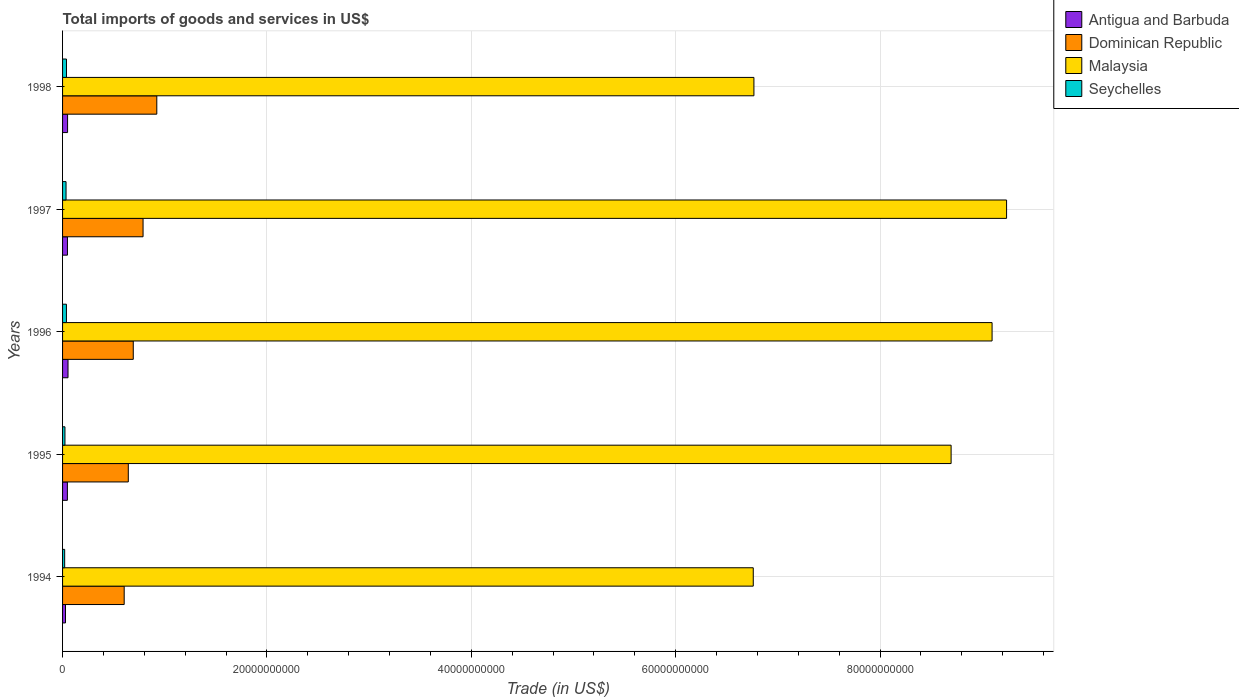How many different coloured bars are there?
Offer a very short reply. 4. How many groups of bars are there?
Make the answer very short. 5. How many bars are there on the 3rd tick from the top?
Offer a very short reply. 4. What is the label of the 1st group of bars from the top?
Keep it short and to the point. 1998. What is the total imports of goods and services in Antigua and Barbuda in 1994?
Provide a succinct answer. 2.86e+08. Across all years, what is the maximum total imports of goods and services in Antigua and Barbuda?
Provide a short and direct response. 5.33e+08. Across all years, what is the minimum total imports of goods and services in Seychelles?
Make the answer very short. 2.06e+08. In which year was the total imports of goods and services in Dominican Republic maximum?
Offer a very short reply. 1998. What is the total total imports of goods and services in Malaysia in the graph?
Provide a succinct answer. 4.06e+11. What is the difference between the total imports of goods and services in Antigua and Barbuda in 1997 and that in 1998?
Provide a succinct answer. -1.16e+07. What is the difference between the total imports of goods and services in Dominican Republic in 1996 and the total imports of goods and services in Antigua and Barbuda in 1998?
Provide a short and direct response. 6.43e+09. What is the average total imports of goods and services in Seychelles per year?
Ensure brevity in your answer.  3.08e+08. In the year 1995, what is the difference between the total imports of goods and services in Seychelles and total imports of goods and services in Antigua and Barbuda?
Your response must be concise. -2.40e+08. What is the ratio of the total imports of goods and services in Dominican Republic in 1994 to that in 1997?
Provide a short and direct response. 0.77. Is the total imports of goods and services in Antigua and Barbuda in 1994 less than that in 1995?
Offer a very short reply. Yes. What is the difference between the highest and the second highest total imports of goods and services in Dominican Republic?
Your response must be concise. 1.34e+09. What is the difference between the highest and the lowest total imports of goods and services in Antigua and Barbuda?
Offer a terse response. 2.47e+08. Is it the case that in every year, the sum of the total imports of goods and services in Antigua and Barbuda and total imports of goods and services in Seychelles is greater than the sum of total imports of goods and services in Dominican Republic and total imports of goods and services in Malaysia?
Your answer should be compact. No. What does the 1st bar from the top in 1994 represents?
Keep it short and to the point. Seychelles. What does the 2nd bar from the bottom in 1998 represents?
Make the answer very short. Dominican Republic. Is it the case that in every year, the sum of the total imports of goods and services in Seychelles and total imports of goods and services in Malaysia is greater than the total imports of goods and services in Dominican Republic?
Keep it short and to the point. Yes. How many bars are there?
Keep it short and to the point. 20. Are all the bars in the graph horizontal?
Give a very brief answer. Yes. How many years are there in the graph?
Provide a succinct answer. 5. Does the graph contain grids?
Give a very brief answer. Yes. Where does the legend appear in the graph?
Ensure brevity in your answer.  Top right. How many legend labels are there?
Make the answer very short. 4. What is the title of the graph?
Your response must be concise. Total imports of goods and services in US$. What is the label or title of the X-axis?
Provide a succinct answer. Trade (in US$). What is the label or title of the Y-axis?
Give a very brief answer. Years. What is the Trade (in US$) in Antigua and Barbuda in 1994?
Provide a succinct answer. 2.86e+08. What is the Trade (in US$) in Dominican Republic in 1994?
Ensure brevity in your answer.  6.03e+09. What is the Trade (in US$) of Malaysia in 1994?
Keep it short and to the point. 6.76e+1. What is the Trade (in US$) in Seychelles in 1994?
Make the answer very short. 2.06e+08. What is the Trade (in US$) in Antigua and Barbuda in 1995?
Provide a succinct answer. 4.72e+08. What is the Trade (in US$) in Dominican Republic in 1995?
Make the answer very short. 6.43e+09. What is the Trade (in US$) of Malaysia in 1995?
Keep it short and to the point. 8.70e+1. What is the Trade (in US$) of Seychelles in 1995?
Keep it short and to the point. 2.33e+08. What is the Trade (in US$) in Antigua and Barbuda in 1996?
Your answer should be compact. 5.33e+08. What is the Trade (in US$) of Dominican Republic in 1996?
Keep it short and to the point. 6.92e+09. What is the Trade (in US$) in Malaysia in 1996?
Give a very brief answer. 9.10e+1. What is the Trade (in US$) of Seychelles in 1996?
Offer a terse response. 3.79e+08. What is the Trade (in US$) of Antigua and Barbuda in 1997?
Your response must be concise. 4.78e+08. What is the Trade (in US$) of Dominican Republic in 1997?
Offer a very short reply. 7.88e+09. What is the Trade (in US$) in Malaysia in 1997?
Offer a terse response. 9.24e+1. What is the Trade (in US$) in Seychelles in 1997?
Your answer should be compact. 3.40e+08. What is the Trade (in US$) of Antigua and Barbuda in 1998?
Provide a short and direct response. 4.90e+08. What is the Trade (in US$) in Dominican Republic in 1998?
Offer a terse response. 9.22e+09. What is the Trade (in US$) of Malaysia in 1998?
Your answer should be very brief. 6.77e+1. What is the Trade (in US$) of Seychelles in 1998?
Your response must be concise. 3.83e+08. Across all years, what is the maximum Trade (in US$) of Antigua and Barbuda?
Give a very brief answer. 5.33e+08. Across all years, what is the maximum Trade (in US$) of Dominican Republic?
Give a very brief answer. 9.22e+09. Across all years, what is the maximum Trade (in US$) of Malaysia?
Provide a succinct answer. 9.24e+1. Across all years, what is the maximum Trade (in US$) in Seychelles?
Your answer should be very brief. 3.83e+08. Across all years, what is the minimum Trade (in US$) in Antigua and Barbuda?
Provide a succinct answer. 2.86e+08. Across all years, what is the minimum Trade (in US$) of Dominican Republic?
Make the answer very short. 6.03e+09. Across all years, what is the minimum Trade (in US$) in Malaysia?
Your answer should be very brief. 6.76e+1. Across all years, what is the minimum Trade (in US$) in Seychelles?
Your answer should be very brief. 2.06e+08. What is the total Trade (in US$) of Antigua and Barbuda in the graph?
Keep it short and to the point. 2.26e+09. What is the total Trade (in US$) in Dominican Republic in the graph?
Ensure brevity in your answer.  3.65e+1. What is the total Trade (in US$) of Malaysia in the graph?
Make the answer very short. 4.06e+11. What is the total Trade (in US$) of Seychelles in the graph?
Your answer should be very brief. 1.54e+09. What is the difference between the Trade (in US$) of Antigua and Barbuda in 1994 and that in 1995?
Keep it short and to the point. -1.86e+08. What is the difference between the Trade (in US$) of Dominican Republic in 1994 and that in 1995?
Your response must be concise. -4.01e+08. What is the difference between the Trade (in US$) of Malaysia in 1994 and that in 1995?
Offer a terse response. -1.94e+1. What is the difference between the Trade (in US$) in Seychelles in 1994 and that in 1995?
Provide a succinct answer. -2.68e+07. What is the difference between the Trade (in US$) in Antigua and Barbuda in 1994 and that in 1996?
Your answer should be very brief. -2.47e+08. What is the difference between the Trade (in US$) of Dominican Republic in 1994 and that in 1996?
Ensure brevity in your answer.  -8.88e+08. What is the difference between the Trade (in US$) in Malaysia in 1994 and that in 1996?
Provide a short and direct response. -2.34e+1. What is the difference between the Trade (in US$) in Seychelles in 1994 and that in 1996?
Provide a succinct answer. -1.72e+08. What is the difference between the Trade (in US$) in Antigua and Barbuda in 1994 and that in 1997?
Make the answer very short. -1.92e+08. What is the difference between the Trade (in US$) of Dominican Republic in 1994 and that in 1997?
Give a very brief answer. -1.85e+09. What is the difference between the Trade (in US$) of Malaysia in 1994 and that in 1997?
Offer a very short reply. -2.48e+1. What is the difference between the Trade (in US$) of Seychelles in 1994 and that in 1997?
Your response must be concise. -1.34e+08. What is the difference between the Trade (in US$) of Antigua and Barbuda in 1994 and that in 1998?
Give a very brief answer. -2.04e+08. What is the difference between the Trade (in US$) of Dominican Republic in 1994 and that in 1998?
Give a very brief answer. -3.19e+09. What is the difference between the Trade (in US$) in Malaysia in 1994 and that in 1998?
Give a very brief answer. -6.37e+07. What is the difference between the Trade (in US$) in Seychelles in 1994 and that in 1998?
Your answer should be very brief. -1.77e+08. What is the difference between the Trade (in US$) of Antigua and Barbuda in 1995 and that in 1996?
Your answer should be compact. -6.09e+07. What is the difference between the Trade (in US$) in Dominican Republic in 1995 and that in 1996?
Offer a terse response. -4.87e+08. What is the difference between the Trade (in US$) in Malaysia in 1995 and that in 1996?
Offer a very short reply. -4.01e+09. What is the difference between the Trade (in US$) in Seychelles in 1995 and that in 1996?
Keep it short and to the point. -1.46e+08. What is the difference between the Trade (in US$) in Antigua and Barbuda in 1995 and that in 1997?
Ensure brevity in your answer.  -5.84e+06. What is the difference between the Trade (in US$) in Dominican Republic in 1995 and that in 1997?
Your answer should be compact. -1.44e+09. What is the difference between the Trade (in US$) in Malaysia in 1995 and that in 1997?
Ensure brevity in your answer.  -5.43e+09. What is the difference between the Trade (in US$) of Seychelles in 1995 and that in 1997?
Provide a succinct answer. -1.08e+08. What is the difference between the Trade (in US$) in Antigua and Barbuda in 1995 and that in 1998?
Offer a very short reply. -1.75e+07. What is the difference between the Trade (in US$) of Dominican Republic in 1995 and that in 1998?
Ensure brevity in your answer.  -2.79e+09. What is the difference between the Trade (in US$) of Malaysia in 1995 and that in 1998?
Your response must be concise. 1.93e+1. What is the difference between the Trade (in US$) of Seychelles in 1995 and that in 1998?
Give a very brief answer. -1.50e+08. What is the difference between the Trade (in US$) of Antigua and Barbuda in 1996 and that in 1997?
Make the answer very short. 5.50e+07. What is the difference between the Trade (in US$) of Dominican Republic in 1996 and that in 1997?
Ensure brevity in your answer.  -9.58e+08. What is the difference between the Trade (in US$) of Malaysia in 1996 and that in 1997?
Provide a short and direct response. -1.42e+09. What is the difference between the Trade (in US$) of Seychelles in 1996 and that in 1997?
Your answer should be very brief. 3.82e+07. What is the difference between the Trade (in US$) of Antigua and Barbuda in 1996 and that in 1998?
Provide a short and direct response. 4.34e+07. What is the difference between the Trade (in US$) in Dominican Republic in 1996 and that in 1998?
Provide a succinct answer. -2.30e+09. What is the difference between the Trade (in US$) in Malaysia in 1996 and that in 1998?
Keep it short and to the point. 2.33e+1. What is the difference between the Trade (in US$) in Seychelles in 1996 and that in 1998?
Your answer should be very brief. -4.37e+06. What is the difference between the Trade (in US$) of Antigua and Barbuda in 1997 and that in 1998?
Give a very brief answer. -1.16e+07. What is the difference between the Trade (in US$) of Dominican Republic in 1997 and that in 1998?
Your response must be concise. -1.34e+09. What is the difference between the Trade (in US$) of Malaysia in 1997 and that in 1998?
Ensure brevity in your answer.  2.47e+1. What is the difference between the Trade (in US$) of Seychelles in 1997 and that in 1998?
Offer a terse response. -4.26e+07. What is the difference between the Trade (in US$) of Antigua and Barbuda in 1994 and the Trade (in US$) of Dominican Republic in 1995?
Provide a succinct answer. -6.15e+09. What is the difference between the Trade (in US$) in Antigua and Barbuda in 1994 and the Trade (in US$) in Malaysia in 1995?
Your answer should be very brief. -8.67e+1. What is the difference between the Trade (in US$) of Antigua and Barbuda in 1994 and the Trade (in US$) of Seychelles in 1995?
Your answer should be very brief. 5.35e+07. What is the difference between the Trade (in US$) of Dominican Republic in 1994 and the Trade (in US$) of Malaysia in 1995?
Provide a succinct answer. -8.09e+1. What is the difference between the Trade (in US$) of Dominican Republic in 1994 and the Trade (in US$) of Seychelles in 1995?
Your answer should be very brief. 5.80e+09. What is the difference between the Trade (in US$) of Malaysia in 1994 and the Trade (in US$) of Seychelles in 1995?
Your response must be concise. 6.74e+1. What is the difference between the Trade (in US$) of Antigua and Barbuda in 1994 and the Trade (in US$) of Dominican Republic in 1996?
Provide a short and direct response. -6.63e+09. What is the difference between the Trade (in US$) of Antigua and Barbuda in 1994 and the Trade (in US$) of Malaysia in 1996?
Provide a short and direct response. -9.07e+1. What is the difference between the Trade (in US$) in Antigua and Barbuda in 1994 and the Trade (in US$) in Seychelles in 1996?
Provide a short and direct response. -9.22e+07. What is the difference between the Trade (in US$) in Dominican Republic in 1994 and the Trade (in US$) in Malaysia in 1996?
Provide a succinct answer. -8.49e+1. What is the difference between the Trade (in US$) of Dominican Republic in 1994 and the Trade (in US$) of Seychelles in 1996?
Provide a succinct answer. 5.65e+09. What is the difference between the Trade (in US$) of Malaysia in 1994 and the Trade (in US$) of Seychelles in 1996?
Give a very brief answer. 6.72e+1. What is the difference between the Trade (in US$) of Antigua and Barbuda in 1994 and the Trade (in US$) of Dominican Republic in 1997?
Ensure brevity in your answer.  -7.59e+09. What is the difference between the Trade (in US$) in Antigua and Barbuda in 1994 and the Trade (in US$) in Malaysia in 1997?
Provide a short and direct response. -9.21e+1. What is the difference between the Trade (in US$) in Antigua and Barbuda in 1994 and the Trade (in US$) in Seychelles in 1997?
Make the answer very short. -5.40e+07. What is the difference between the Trade (in US$) in Dominican Republic in 1994 and the Trade (in US$) in Malaysia in 1997?
Make the answer very short. -8.63e+1. What is the difference between the Trade (in US$) in Dominican Republic in 1994 and the Trade (in US$) in Seychelles in 1997?
Offer a very short reply. 5.69e+09. What is the difference between the Trade (in US$) of Malaysia in 1994 and the Trade (in US$) of Seychelles in 1997?
Give a very brief answer. 6.73e+1. What is the difference between the Trade (in US$) in Antigua and Barbuda in 1994 and the Trade (in US$) in Dominican Republic in 1998?
Make the answer very short. -8.93e+09. What is the difference between the Trade (in US$) of Antigua and Barbuda in 1994 and the Trade (in US$) of Malaysia in 1998?
Ensure brevity in your answer.  -6.74e+1. What is the difference between the Trade (in US$) in Antigua and Barbuda in 1994 and the Trade (in US$) in Seychelles in 1998?
Ensure brevity in your answer.  -9.66e+07. What is the difference between the Trade (in US$) in Dominican Republic in 1994 and the Trade (in US$) in Malaysia in 1998?
Give a very brief answer. -6.16e+1. What is the difference between the Trade (in US$) of Dominican Republic in 1994 and the Trade (in US$) of Seychelles in 1998?
Your answer should be very brief. 5.65e+09. What is the difference between the Trade (in US$) in Malaysia in 1994 and the Trade (in US$) in Seychelles in 1998?
Offer a terse response. 6.72e+1. What is the difference between the Trade (in US$) of Antigua and Barbuda in 1995 and the Trade (in US$) of Dominican Republic in 1996?
Provide a succinct answer. -6.45e+09. What is the difference between the Trade (in US$) in Antigua and Barbuda in 1995 and the Trade (in US$) in Malaysia in 1996?
Provide a short and direct response. -9.05e+1. What is the difference between the Trade (in US$) in Antigua and Barbuda in 1995 and the Trade (in US$) in Seychelles in 1996?
Give a very brief answer. 9.38e+07. What is the difference between the Trade (in US$) in Dominican Republic in 1995 and the Trade (in US$) in Malaysia in 1996?
Keep it short and to the point. -8.45e+1. What is the difference between the Trade (in US$) in Dominican Republic in 1995 and the Trade (in US$) in Seychelles in 1996?
Your answer should be compact. 6.05e+09. What is the difference between the Trade (in US$) of Malaysia in 1995 and the Trade (in US$) of Seychelles in 1996?
Make the answer very short. 8.66e+1. What is the difference between the Trade (in US$) of Antigua and Barbuda in 1995 and the Trade (in US$) of Dominican Republic in 1997?
Your answer should be very brief. -7.40e+09. What is the difference between the Trade (in US$) in Antigua and Barbuda in 1995 and the Trade (in US$) in Malaysia in 1997?
Your response must be concise. -9.19e+1. What is the difference between the Trade (in US$) of Antigua and Barbuda in 1995 and the Trade (in US$) of Seychelles in 1997?
Your answer should be very brief. 1.32e+08. What is the difference between the Trade (in US$) in Dominican Republic in 1995 and the Trade (in US$) in Malaysia in 1997?
Provide a short and direct response. -8.59e+1. What is the difference between the Trade (in US$) of Dominican Republic in 1995 and the Trade (in US$) of Seychelles in 1997?
Keep it short and to the point. 6.09e+09. What is the difference between the Trade (in US$) of Malaysia in 1995 and the Trade (in US$) of Seychelles in 1997?
Keep it short and to the point. 8.66e+1. What is the difference between the Trade (in US$) of Antigua and Barbuda in 1995 and the Trade (in US$) of Dominican Republic in 1998?
Offer a terse response. -8.75e+09. What is the difference between the Trade (in US$) in Antigua and Barbuda in 1995 and the Trade (in US$) in Malaysia in 1998?
Make the answer very short. -6.72e+1. What is the difference between the Trade (in US$) in Antigua and Barbuda in 1995 and the Trade (in US$) in Seychelles in 1998?
Provide a succinct answer. 8.94e+07. What is the difference between the Trade (in US$) of Dominican Republic in 1995 and the Trade (in US$) of Malaysia in 1998?
Your answer should be compact. -6.12e+1. What is the difference between the Trade (in US$) in Dominican Republic in 1995 and the Trade (in US$) in Seychelles in 1998?
Provide a succinct answer. 6.05e+09. What is the difference between the Trade (in US$) of Malaysia in 1995 and the Trade (in US$) of Seychelles in 1998?
Ensure brevity in your answer.  8.66e+1. What is the difference between the Trade (in US$) of Antigua and Barbuda in 1996 and the Trade (in US$) of Dominican Republic in 1997?
Offer a terse response. -7.34e+09. What is the difference between the Trade (in US$) in Antigua and Barbuda in 1996 and the Trade (in US$) in Malaysia in 1997?
Keep it short and to the point. -9.18e+1. What is the difference between the Trade (in US$) in Antigua and Barbuda in 1996 and the Trade (in US$) in Seychelles in 1997?
Your response must be concise. 1.93e+08. What is the difference between the Trade (in US$) of Dominican Republic in 1996 and the Trade (in US$) of Malaysia in 1997?
Your answer should be compact. -8.55e+1. What is the difference between the Trade (in US$) in Dominican Republic in 1996 and the Trade (in US$) in Seychelles in 1997?
Provide a succinct answer. 6.58e+09. What is the difference between the Trade (in US$) in Malaysia in 1996 and the Trade (in US$) in Seychelles in 1997?
Your response must be concise. 9.06e+1. What is the difference between the Trade (in US$) in Antigua and Barbuda in 1996 and the Trade (in US$) in Dominican Republic in 1998?
Ensure brevity in your answer.  -8.69e+09. What is the difference between the Trade (in US$) in Antigua and Barbuda in 1996 and the Trade (in US$) in Malaysia in 1998?
Offer a terse response. -6.71e+1. What is the difference between the Trade (in US$) in Antigua and Barbuda in 1996 and the Trade (in US$) in Seychelles in 1998?
Provide a succinct answer. 1.50e+08. What is the difference between the Trade (in US$) in Dominican Republic in 1996 and the Trade (in US$) in Malaysia in 1998?
Ensure brevity in your answer.  -6.07e+1. What is the difference between the Trade (in US$) of Dominican Republic in 1996 and the Trade (in US$) of Seychelles in 1998?
Your response must be concise. 6.54e+09. What is the difference between the Trade (in US$) of Malaysia in 1996 and the Trade (in US$) of Seychelles in 1998?
Make the answer very short. 9.06e+1. What is the difference between the Trade (in US$) in Antigua and Barbuda in 1997 and the Trade (in US$) in Dominican Republic in 1998?
Provide a succinct answer. -8.74e+09. What is the difference between the Trade (in US$) in Antigua and Barbuda in 1997 and the Trade (in US$) in Malaysia in 1998?
Provide a succinct answer. -6.72e+1. What is the difference between the Trade (in US$) of Antigua and Barbuda in 1997 and the Trade (in US$) of Seychelles in 1998?
Make the answer very short. 9.53e+07. What is the difference between the Trade (in US$) of Dominican Republic in 1997 and the Trade (in US$) of Malaysia in 1998?
Offer a terse response. -5.98e+1. What is the difference between the Trade (in US$) of Dominican Republic in 1997 and the Trade (in US$) of Seychelles in 1998?
Provide a short and direct response. 7.49e+09. What is the difference between the Trade (in US$) in Malaysia in 1997 and the Trade (in US$) in Seychelles in 1998?
Ensure brevity in your answer.  9.20e+1. What is the average Trade (in US$) of Antigua and Barbuda per year?
Make the answer very short. 4.52e+08. What is the average Trade (in US$) of Dominican Republic per year?
Ensure brevity in your answer.  7.30e+09. What is the average Trade (in US$) of Malaysia per year?
Make the answer very short. 8.11e+1. What is the average Trade (in US$) in Seychelles per year?
Offer a very short reply. 3.08e+08. In the year 1994, what is the difference between the Trade (in US$) in Antigua and Barbuda and Trade (in US$) in Dominican Republic?
Your answer should be very brief. -5.74e+09. In the year 1994, what is the difference between the Trade (in US$) in Antigua and Barbuda and Trade (in US$) in Malaysia?
Make the answer very short. -6.73e+1. In the year 1994, what is the difference between the Trade (in US$) in Antigua and Barbuda and Trade (in US$) in Seychelles?
Provide a short and direct response. 8.02e+07. In the year 1994, what is the difference between the Trade (in US$) of Dominican Republic and Trade (in US$) of Malaysia?
Your answer should be compact. -6.16e+1. In the year 1994, what is the difference between the Trade (in US$) in Dominican Republic and Trade (in US$) in Seychelles?
Give a very brief answer. 5.82e+09. In the year 1994, what is the difference between the Trade (in US$) in Malaysia and Trade (in US$) in Seychelles?
Ensure brevity in your answer.  6.74e+1. In the year 1995, what is the difference between the Trade (in US$) in Antigua and Barbuda and Trade (in US$) in Dominican Republic?
Provide a succinct answer. -5.96e+09. In the year 1995, what is the difference between the Trade (in US$) of Antigua and Barbuda and Trade (in US$) of Malaysia?
Give a very brief answer. -8.65e+1. In the year 1995, what is the difference between the Trade (in US$) of Antigua and Barbuda and Trade (in US$) of Seychelles?
Keep it short and to the point. 2.40e+08. In the year 1995, what is the difference between the Trade (in US$) in Dominican Republic and Trade (in US$) in Malaysia?
Your response must be concise. -8.05e+1. In the year 1995, what is the difference between the Trade (in US$) of Dominican Republic and Trade (in US$) of Seychelles?
Your response must be concise. 6.20e+09. In the year 1995, what is the difference between the Trade (in US$) of Malaysia and Trade (in US$) of Seychelles?
Ensure brevity in your answer.  8.67e+1. In the year 1996, what is the difference between the Trade (in US$) of Antigua and Barbuda and Trade (in US$) of Dominican Republic?
Ensure brevity in your answer.  -6.39e+09. In the year 1996, what is the difference between the Trade (in US$) in Antigua and Barbuda and Trade (in US$) in Malaysia?
Provide a succinct answer. -9.04e+1. In the year 1996, what is the difference between the Trade (in US$) in Antigua and Barbuda and Trade (in US$) in Seychelles?
Offer a terse response. 1.55e+08. In the year 1996, what is the difference between the Trade (in US$) of Dominican Republic and Trade (in US$) of Malaysia?
Give a very brief answer. -8.40e+1. In the year 1996, what is the difference between the Trade (in US$) of Dominican Republic and Trade (in US$) of Seychelles?
Your response must be concise. 6.54e+09. In the year 1996, what is the difference between the Trade (in US$) of Malaysia and Trade (in US$) of Seychelles?
Your response must be concise. 9.06e+1. In the year 1997, what is the difference between the Trade (in US$) of Antigua and Barbuda and Trade (in US$) of Dominican Republic?
Offer a very short reply. -7.40e+09. In the year 1997, what is the difference between the Trade (in US$) of Antigua and Barbuda and Trade (in US$) of Malaysia?
Make the answer very short. -9.19e+1. In the year 1997, what is the difference between the Trade (in US$) in Antigua and Barbuda and Trade (in US$) in Seychelles?
Your answer should be very brief. 1.38e+08. In the year 1997, what is the difference between the Trade (in US$) in Dominican Republic and Trade (in US$) in Malaysia?
Your answer should be very brief. -8.45e+1. In the year 1997, what is the difference between the Trade (in US$) in Dominican Republic and Trade (in US$) in Seychelles?
Provide a succinct answer. 7.54e+09. In the year 1997, what is the difference between the Trade (in US$) of Malaysia and Trade (in US$) of Seychelles?
Give a very brief answer. 9.20e+1. In the year 1998, what is the difference between the Trade (in US$) in Antigua and Barbuda and Trade (in US$) in Dominican Republic?
Keep it short and to the point. -8.73e+09. In the year 1998, what is the difference between the Trade (in US$) of Antigua and Barbuda and Trade (in US$) of Malaysia?
Make the answer very short. -6.72e+1. In the year 1998, what is the difference between the Trade (in US$) in Antigua and Barbuda and Trade (in US$) in Seychelles?
Offer a terse response. 1.07e+08. In the year 1998, what is the difference between the Trade (in US$) in Dominican Republic and Trade (in US$) in Malaysia?
Your answer should be very brief. -5.84e+1. In the year 1998, what is the difference between the Trade (in US$) in Dominican Republic and Trade (in US$) in Seychelles?
Keep it short and to the point. 8.84e+09. In the year 1998, what is the difference between the Trade (in US$) of Malaysia and Trade (in US$) of Seychelles?
Provide a short and direct response. 6.73e+1. What is the ratio of the Trade (in US$) of Antigua and Barbuda in 1994 to that in 1995?
Make the answer very short. 0.61. What is the ratio of the Trade (in US$) of Dominican Republic in 1994 to that in 1995?
Your answer should be very brief. 0.94. What is the ratio of the Trade (in US$) of Malaysia in 1994 to that in 1995?
Provide a short and direct response. 0.78. What is the ratio of the Trade (in US$) in Seychelles in 1994 to that in 1995?
Your answer should be compact. 0.89. What is the ratio of the Trade (in US$) in Antigua and Barbuda in 1994 to that in 1996?
Your answer should be compact. 0.54. What is the ratio of the Trade (in US$) of Dominican Republic in 1994 to that in 1996?
Your answer should be very brief. 0.87. What is the ratio of the Trade (in US$) of Malaysia in 1994 to that in 1996?
Offer a very short reply. 0.74. What is the ratio of the Trade (in US$) in Seychelles in 1994 to that in 1996?
Provide a succinct answer. 0.54. What is the ratio of the Trade (in US$) of Antigua and Barbuda in 1994 to that in 1997?
Provide a short and direct response. 0.6. What is the ratio of the Trade (in US$) in Dominican Republic in 1994 to that in 1997?
Ensure brevity in your answer.  0.77. What is the ratio of the Trade (in US$) of Malaysia in 1994 to that in 1997?
Your response must be concise. 0.73. What is the ratio of the Trade (in US$) in Seychelles in 1994 to that in 1997?
Your answer should be compact. 0.61. What is the ratio of the Trade (in US$) in Antigua and Barbuda in 1994 to that in 1998?
Your response must be concise. 0.58. What is the ratio of the Trade (in US$) of Dominican Republic in 1994 to that in 1998?
Your response must be concise. 0.65. What is the ratio of the Trade (in US$) of Seychelles in 1994 to that in 1998?
Offer a very short reply. 0.54. What is the ratio of the Trade (in US$) in Antigua and Barbuda in 1995 to that in 1996?
Your answer should be very brief. 0.89. What is the ratio of the Trade (in US$) in Dominican Republic in 1995 to that in 1996?
Your answer should be compact. 0.93. What is the ratio of the Trade (in US$) in Malaysia in 1995 to that in 1996?
Provide a short and direct response. 0.96. What is the ratio of the Trade (in US$) in Seychelles in 1995 to that in 1996?
Your answer should be compact. 0.62. What is the ratio of the Trade (in US$) in Antigua and Barbuda in 1995 to that in 1997?
Give a very brief answer. 0.99. What is the ratio of the Trade (in US$) in Dominican Republic in 1995 to that in 1997?
Ensure brevity in your answer.  0.82. What is the ratio of the Trade (in US$) of Malaysia in 1995 to that in 1997?
Give a very brief answer. 0.94. What is the ratio of the Trade (in US$) in Seychelles in 1995 to that in 1997?
Offer a terse response. 0.68. What is the ratio of the Trade (in US$) of Antigua and Barbuda in 1995 to that in 1998?
Your response must be concise. 0.96. What is the ratio of the Trade (in US$) of Dominican Republic in 1995 to that in 1998?
Keep it short and to the point. 0.7. What is the ratio of the Trade (in US$) in Malaysia in 1995 to that in 1998?
Your answer should be compact. 1.29. What is the ratio of the Trade (in US$) of Seychelles in 1995 to that in 1998?
Give a very brief answer. 0.61. What is the ratio of the Trade (in US$) in Antigua and Barbuda in 1996 to that in 1997?
Your answer should be compact. 1.11. What is the ratio of the Trade (in US$) in Dominican Republic in 1996 to that in 1997?
Keep it short and to the point. 0.88. What is the ratio of the Trade (in US$) in Malaysia in 1996 to that in 1997?
Offer a terse response. 0.98. What is the ratio of the Trade (in US$) of Seychelles in 1996 to that in 1997?
Your answer should be compact. 1.11. What is the ratio of the Trade (in US$) of Antigua and Barbuda in 1996 to that in 1998?
Offer a very short reply. 1.09. What is the ratio of the Trade (in US$) in Dominican Republic in 1996 to that in 1998?
Your answer should be compact. 0.75. What is the ratio of the Trade (in US$) of Malaysia in 1996 to that in 1998?
Your answer should be very brief. 1.34. What is the ratio of the Trade (in US$) of Seychelles in 1996 to that in 1998?
Give a very brief answer. 0.99. What is the ratio of the Trade (in US$) in Antigua and Barbuda in 1997 to that in 1998?
Your answer should be very brief. 0.98. What is the ratio of the Trade (in US$) in Dominican Republic in 1997 to that in 1998?
Your answer should be compact. 0.85. What is the ratio of the Trade (in US$) of Malaysia in 1997 to that in 1998?
Ensure brevity in your answer.  1.37. What is the ratio of the Trade (in US$) of Seychelles in 1997 to that in 1998?
Your answer should be compact. 0.89. What is the difference between the highest and the second highest Trade (in US$) in Antigua and Barbuda?
Keep it short and to the point. 4.34e+07. What is the difference between the highest and the second highest Trade (in US$) of Dominican Republic?
Ensure brevity in your answer.  1.34e+09. What is the difference between the highest and the second highest Trade (in US$) of Malaysia?
Your response must be concise. 1.42e+09. What is the difference between the highest and the second highest Trade (in US$) in Seychelles?
Make the answer very short. 4.37e+06. What is the difference between the highest and the lowest Trade (in US$) in Antigua and Barbuda?
Provide a short and direct response. 2.47e+08. What is the difference between the highest and the lowest Trade (in US$) in Dominican Republic?
Make the answer very short. 3.19e+09. What is the difference between the highest and the lowest Trade (in US$) of Malaysia?
Offer a very short reply. 2.48e+1. What is the difference between the highest and the lowest Trade (in US$) of Seychelles?
Your response must be concise. 1.77e+08. 